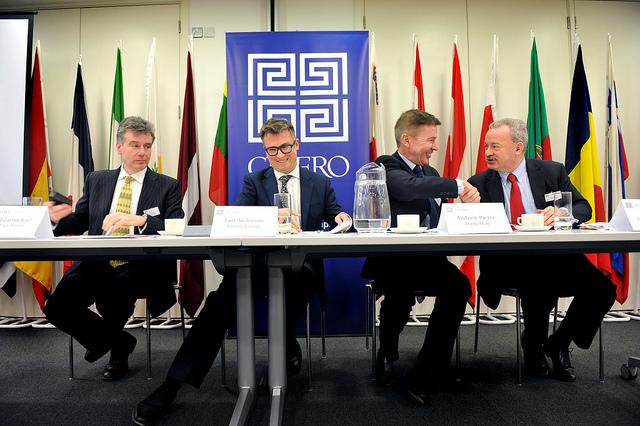Are the people featured in this picture happy?
Concise answer only. Yes. Who is wearing a suit?
Concise answer only. Everyone. How many people at the table?
Concise answer only. 4. 